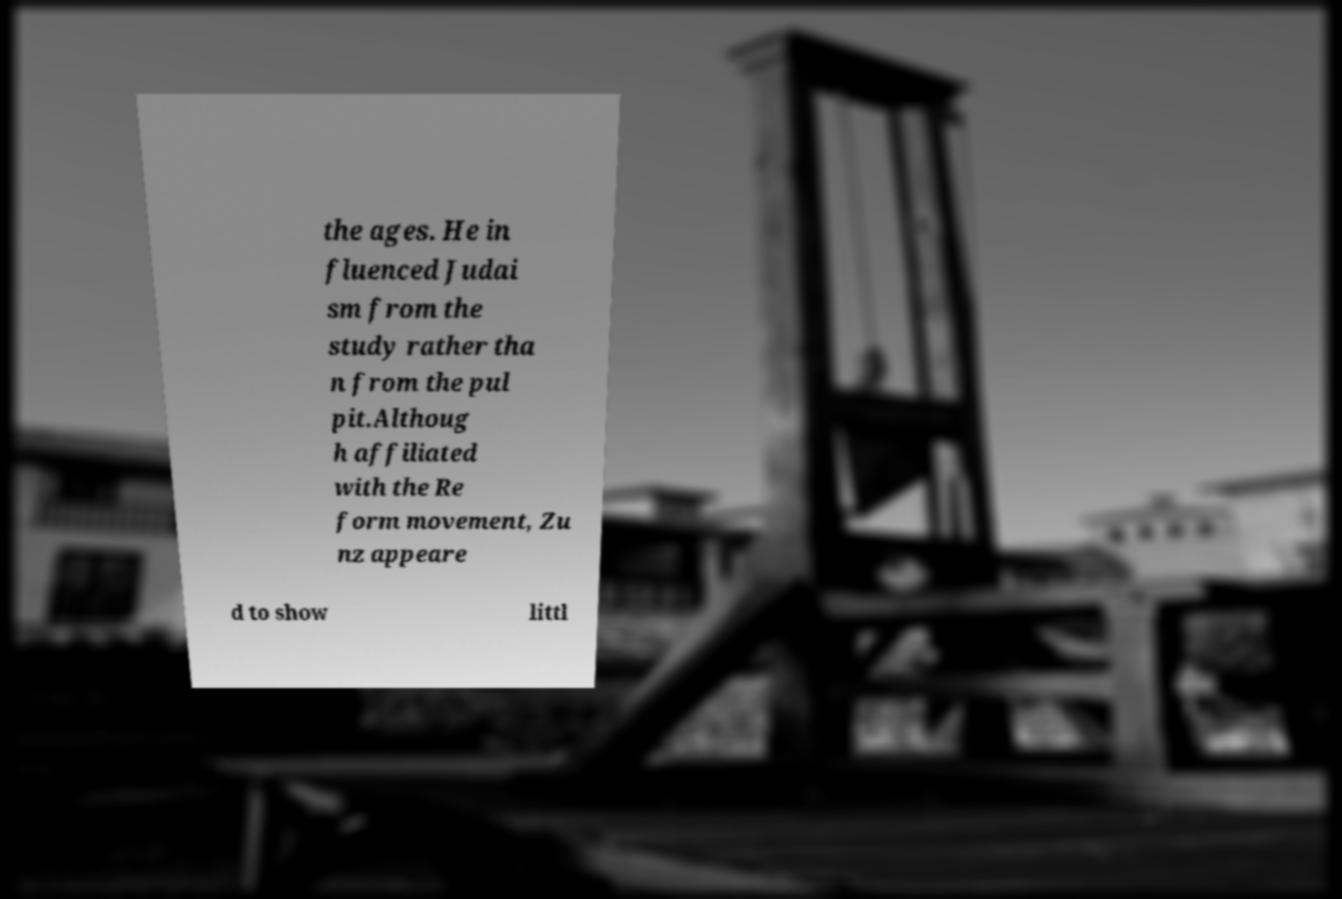There's text embedded in this image that I need extracted. Can you transcribe it verbatim? the ages. He in fluenced Judai sm from the study rather tha n from the pul pit.Althoug h affiliated with the Re form movement, Zu nz appeare d to show littl 